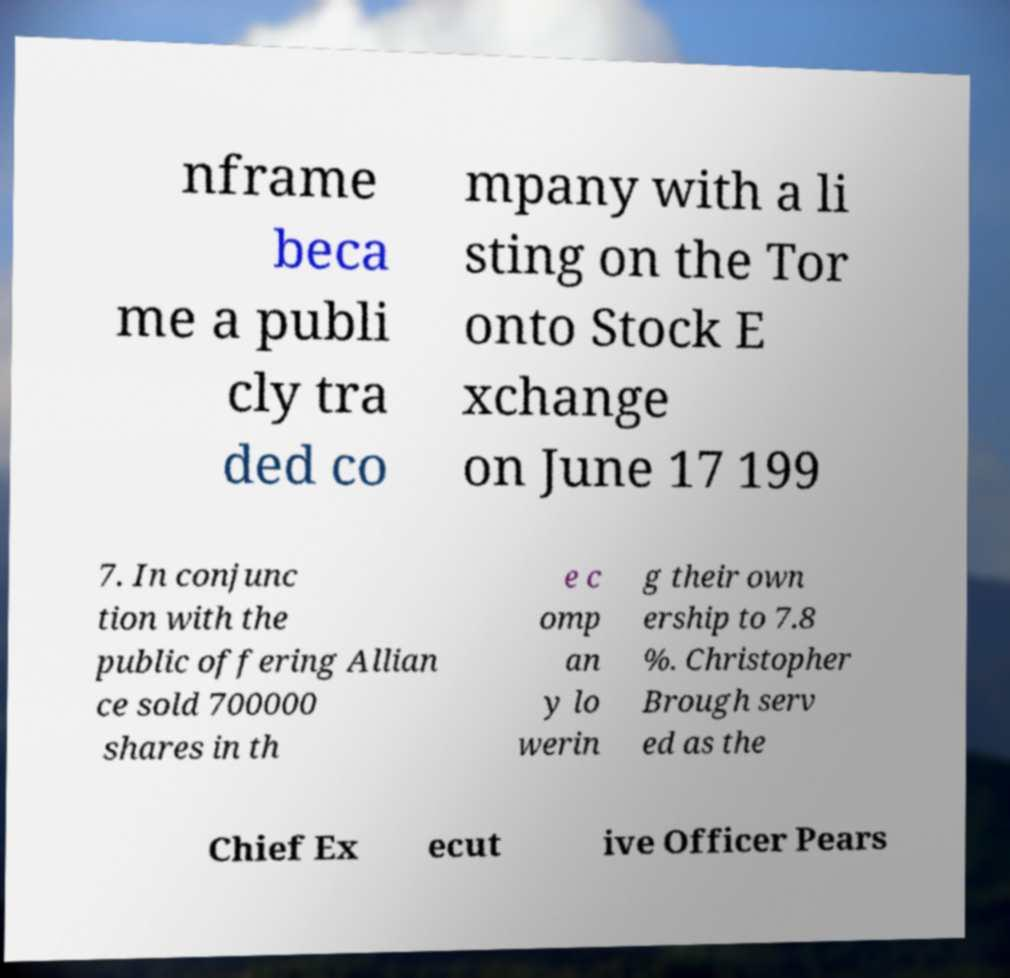Can you read and provide the text displayed in the image?This photo seems to have some interesting text. Can you extract and type it out for me? nframe beca me a publi cly tra ded co mpany with a li sting on the Tor onto Stock E xchange on June 17 199 7. In conjunc tion with the public offering Allian ce sold 700000 shares in th e c omp an y lo werin g their own ership to 7.8 %. Christopher Brough serv ed as the Chief Ex ecut ive Officer Pears 